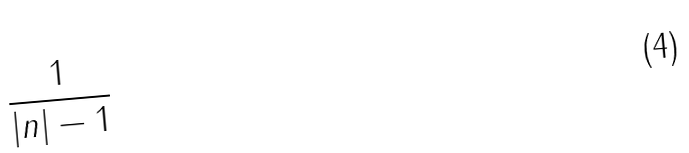<formula> <loc_0><loc_0><loc_500><loc_500>\frac { 1 } { | n | - 1 }</formula> 